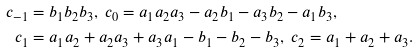<formula> <loc_0><loc_0><loc_500><loc_500>c _ { - 1 } & = b _ { 1 } b _ { 2 } b _ { 3 } , \ c _ { 0 } = a _ { 1 } a _ { 2 } a _ { 3 } - a _ { 2 } b _ { 1 } - a _ { 3 } b _ { 2 } - a _ { 1 } b _ { 3 } , \\ c _ { 1 } & = a _ { 1 } a _ { 2 } + a _ { 2 } a _ { 3 } + a _ { 3 } a _ { 1 } - b _ { 1 } - b _ { 2 } - b _ { 3 } , \ c _ { 2 } = a _ { 1 } + a _ { 2 } + a _ { 3 } .</formula> 